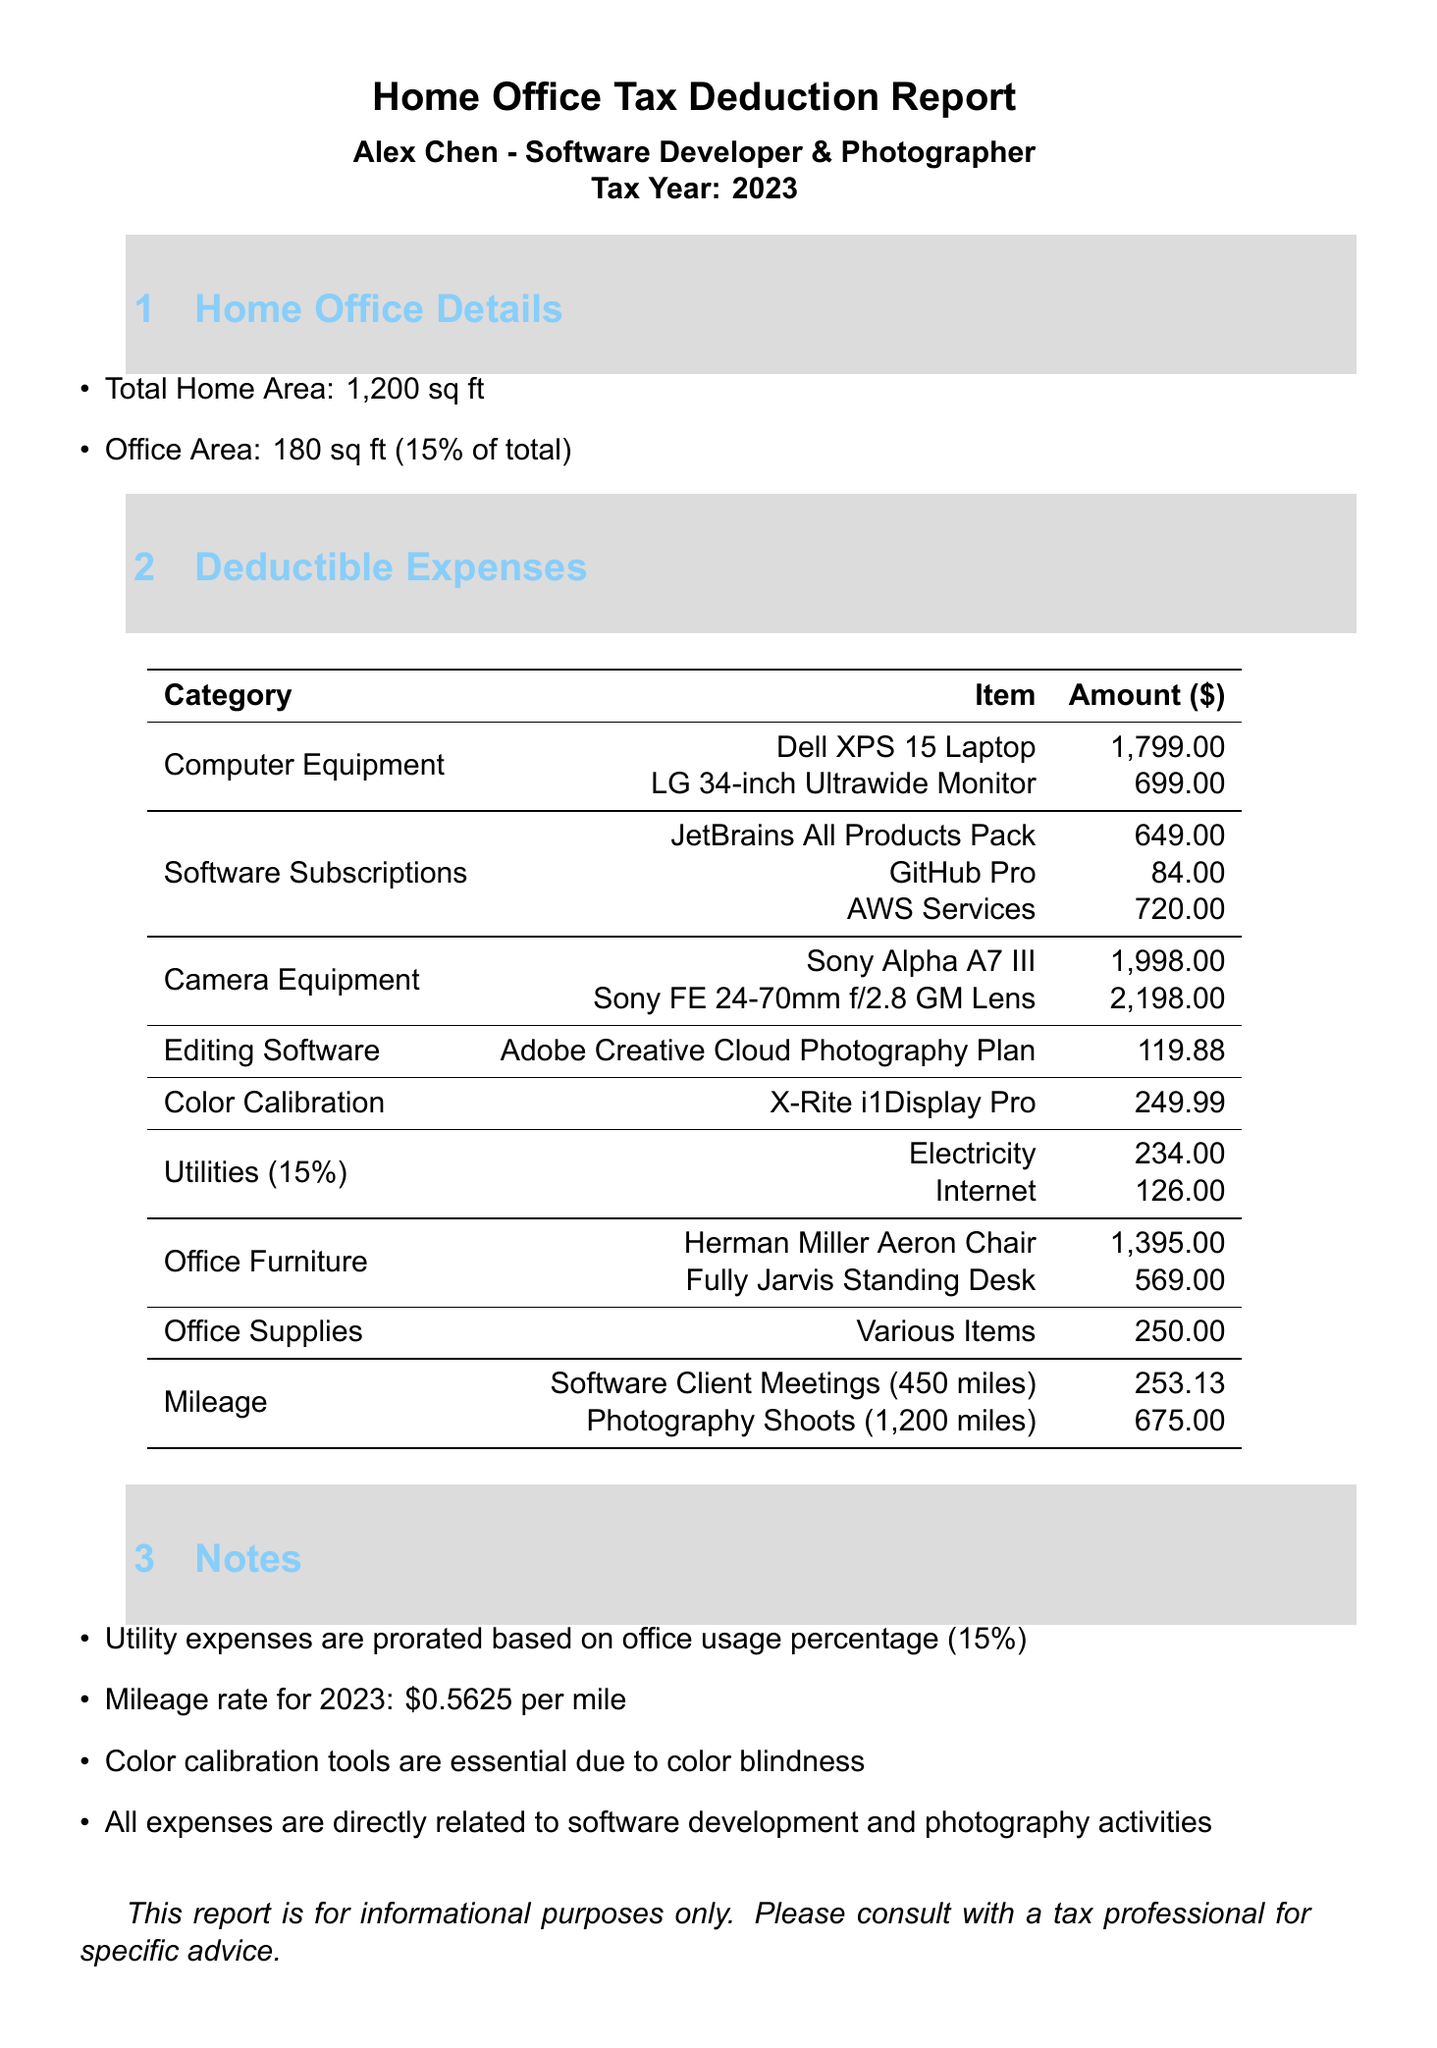what is the total home area? The total home area is stated in the home office details section, which is 1200 sq ft.
Answer: 1200 sq ft what is the office area? The office area is specified as 180 sq ft in the home office details section.
Answer: 180 sq ft how much did the Sony Alpha A7 III cost? The cost of the Sony Alpha A7 III is listed under camera equipment expenses, which is $1998.
Answer: 1998 what percentage of the home is used for the office? The office usage percentage is provided in the home office details section as 15%.
Answer: 15% what is the deductible amount for mileage related to photography shoots? The mileage amount for photography shoots is $675, as noted in the mileage section of the report.
Answer: 675 total expenses for software subscriptions? The total expenses for software subscriptions are calculated from individual software costs: $649 + $84 + $720 = $1453.
Answer: 1453 how much are the utility expenses prorated based on office usage percentage? The utility expenses for electricity and internet are noted as $234 and $126, respectively, for a total of $360, prorated at 15%.
Answer: 360 what is the cost of the color calibration tool? The cost of the color calibration tool, X-Rite i1Display Pro, is listed as $249.99 in the document.
Answer: 249.99 how many miles were driven for software client meetings? The document states that 450 miles were driven for software client meetings, noted in the mileage section.
Answer: 450 